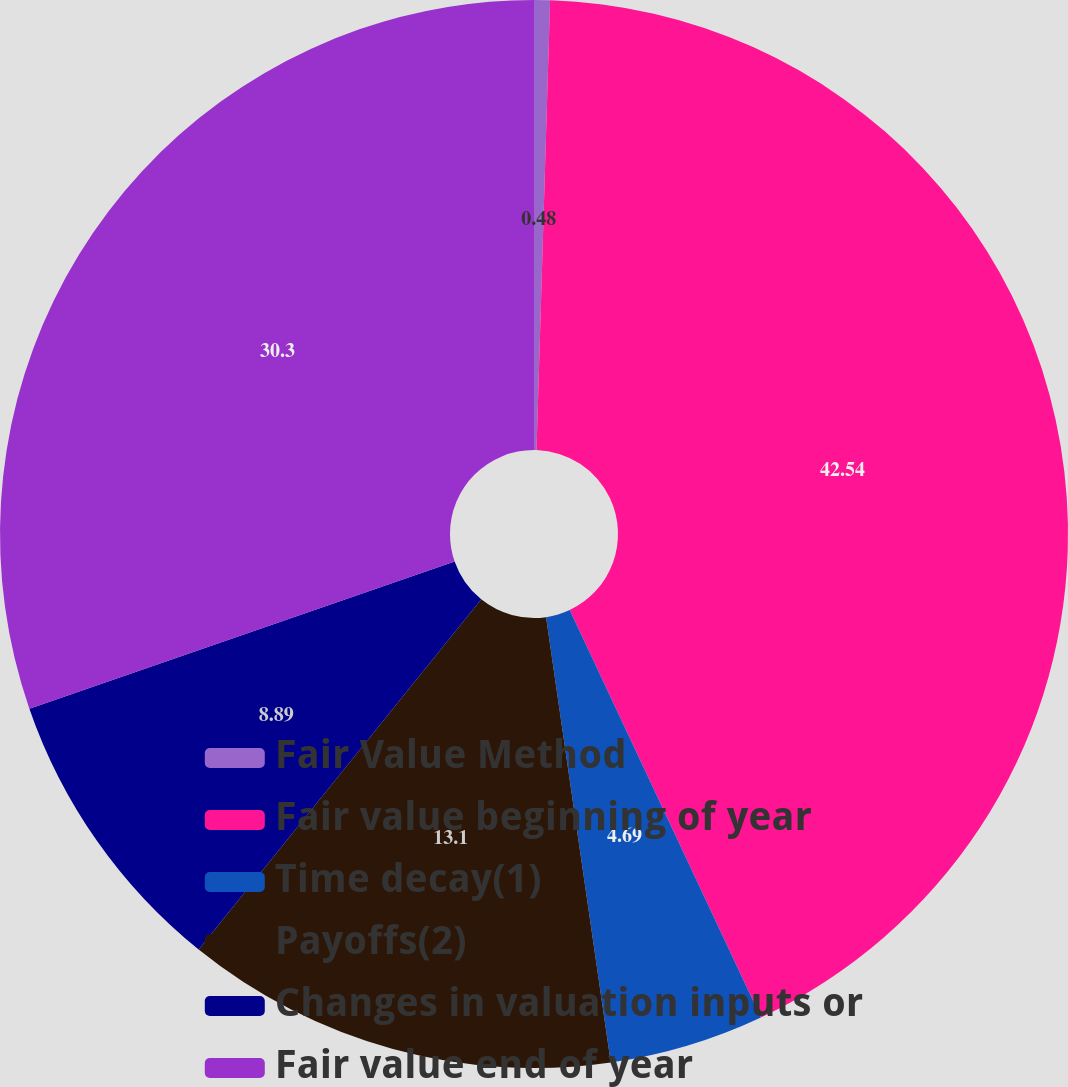Convert chart to OTSL. <chart><loc_0><loc_0><loc_500><loc_500><pie_chart><fcel>Fair Value Method<fcel>Fair value beginning of year<fcel>Time decay(1)<fcel>Payoffs(2)<fcel>Changes in valuation inputs or<fcel>Fair value end of year<nl><fcel>0.48%<fcel>42.53%<fcel>4.69%<fcel>13.1%<fcel>8.89%<fcel>30.3%<nl></chart> 